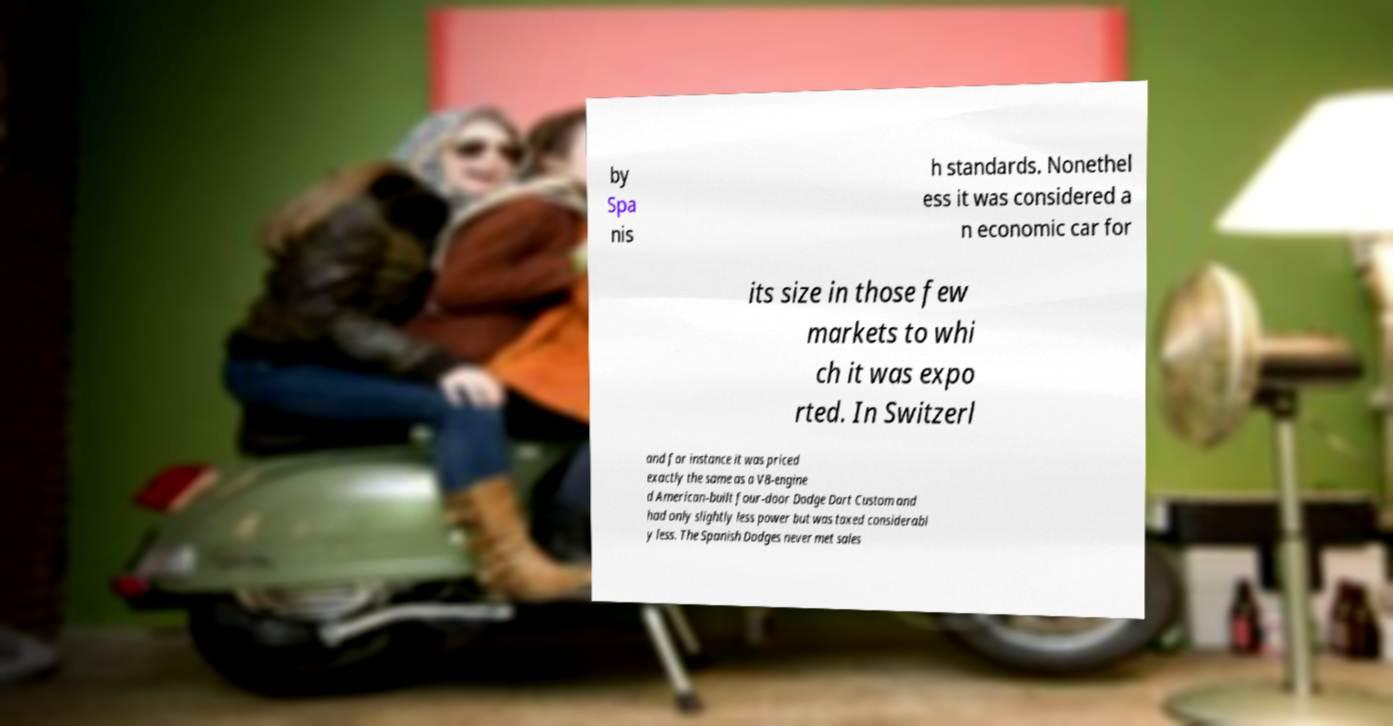Can you read and provide the text displayed in the image?This photo seems to have some interesting text. Can you extract and type it out for me? by Spa nis h standards. Nonethel ess it was considered a n economic car for its size in those few markets to whi ch it was expo rted. In Switzerl and for instance it was priced exactly the same as a V8-engine d American-built four-door Dodge Dart Custom and had only slightly less power but was taxed considerabl y less. The Spanish Dodges never met sales 